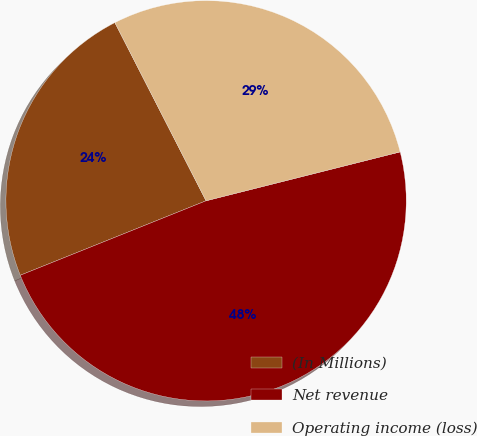<chart> <loc_0><loc_0><loc_500><loc_500><pie_chart><fcel>(In Millions)<fcel>Net revenue<fcel>Operating income (loss)<nl><fcel>23.54%<fcel>47.86%<fcel>28.6%<nl></chart> 